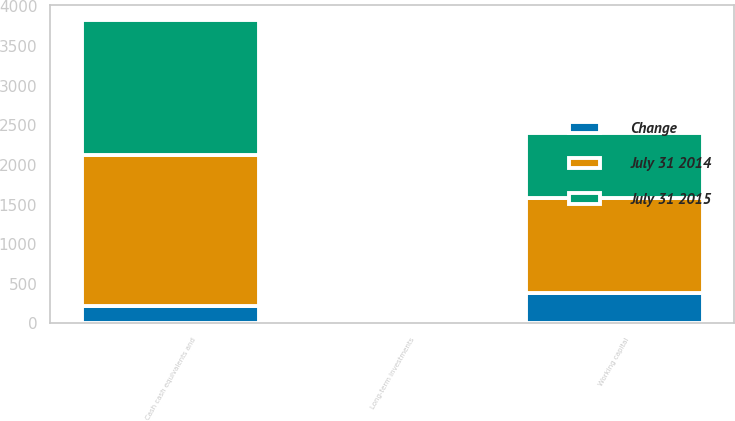<chart> <loc_0><loc_0><loc_500><loc_500><stacked_bar_chart><ecel><fcel>Cash cash equivalents and<fcel>Long-term investments<fcel>Working capital<nl><fcel>July 31 2015<fcel>1697<fcel>27<fcel>816<nl><fcel>July 31 2014<fcel>1914<fcel>31<fcel>1200<nl><fcel>Change<fcel>217<fcel>4<fcel>384<nl></chart> 